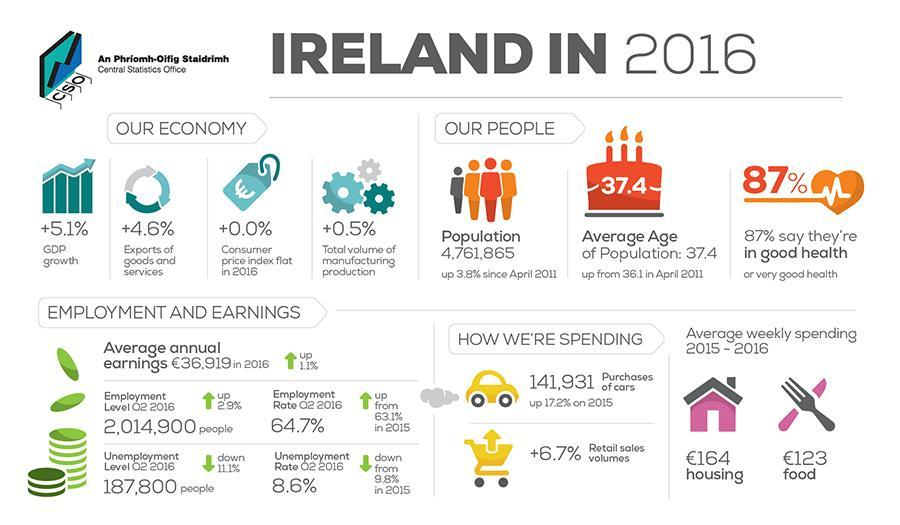What is the percentage of people who are not in good health?
Answer the question with a short phrase. 13% What is the number of peoples icon are in this infographic? 4 What is the unemployment rate? 8.6% What is the employment rate? 64.7% 